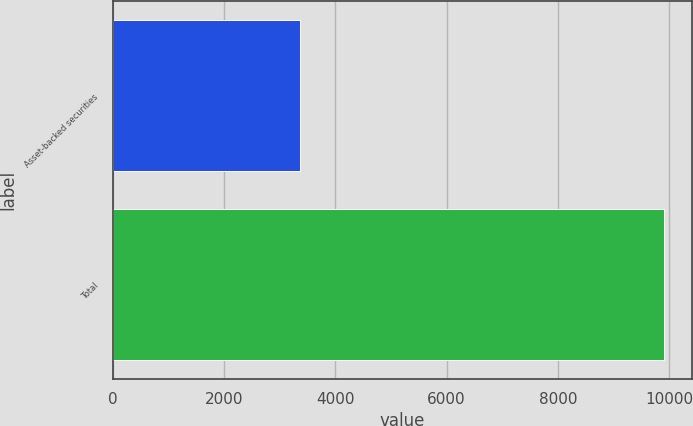Convert chart to OTSL. <chart><loc_0><loc_0><loc_500><loc_500><bar_chart><fcel>Asset-backed securities<fcel>Total<nl><fcel>3367<fcel>9909<nl></chart> 